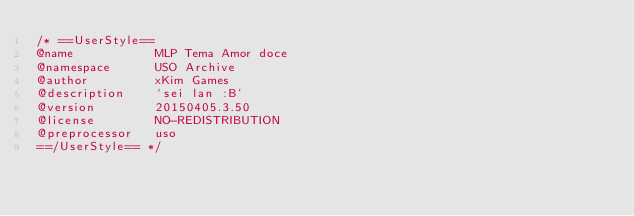<code> <loc_0><loc_0><loc_500><loc_500><_CSS_>/* ==UserStyle==
@name           MLP Tema Amor doce
@namespace      USO Archive
@author         xKim Games
@description    `sei lan :B`
@version        20150405.3.50
@license        NO-REDISTRIBUTION
@preprocessor   uso
==/UserStyle== */</code> 